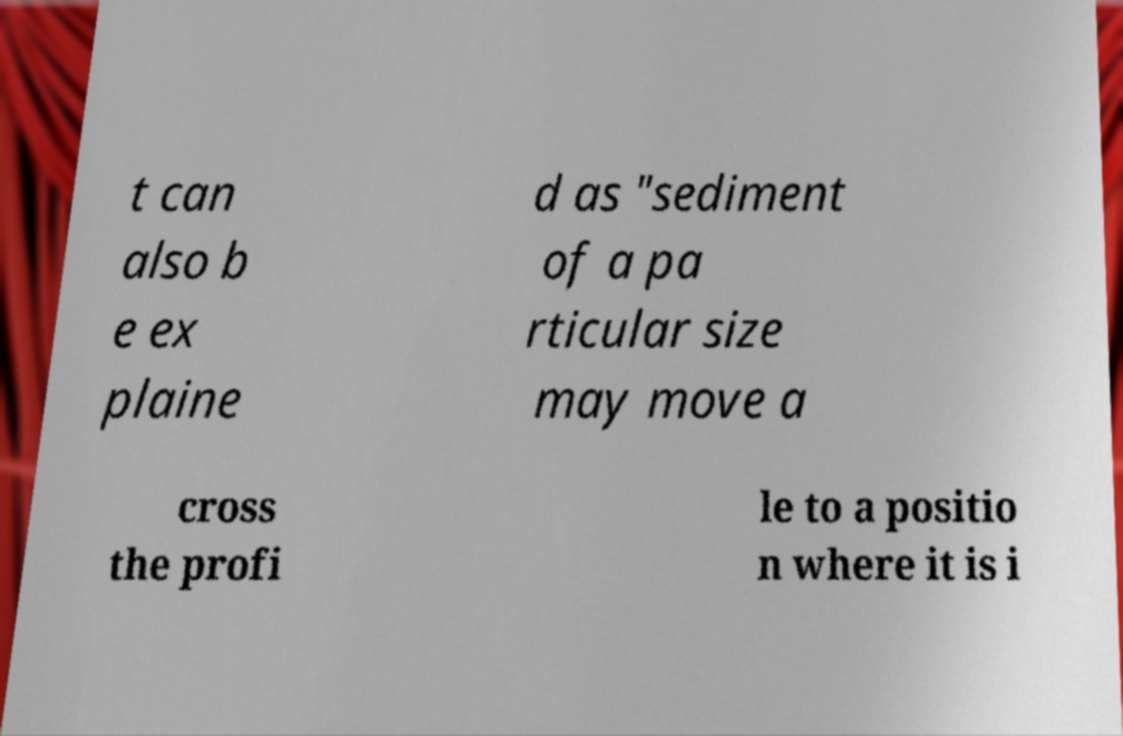Please identify and transcribe the text found in this image. t can also b e ex plaine d as "sediment of a pa rticular size may move a cross the profi le to a positio n where it is i 